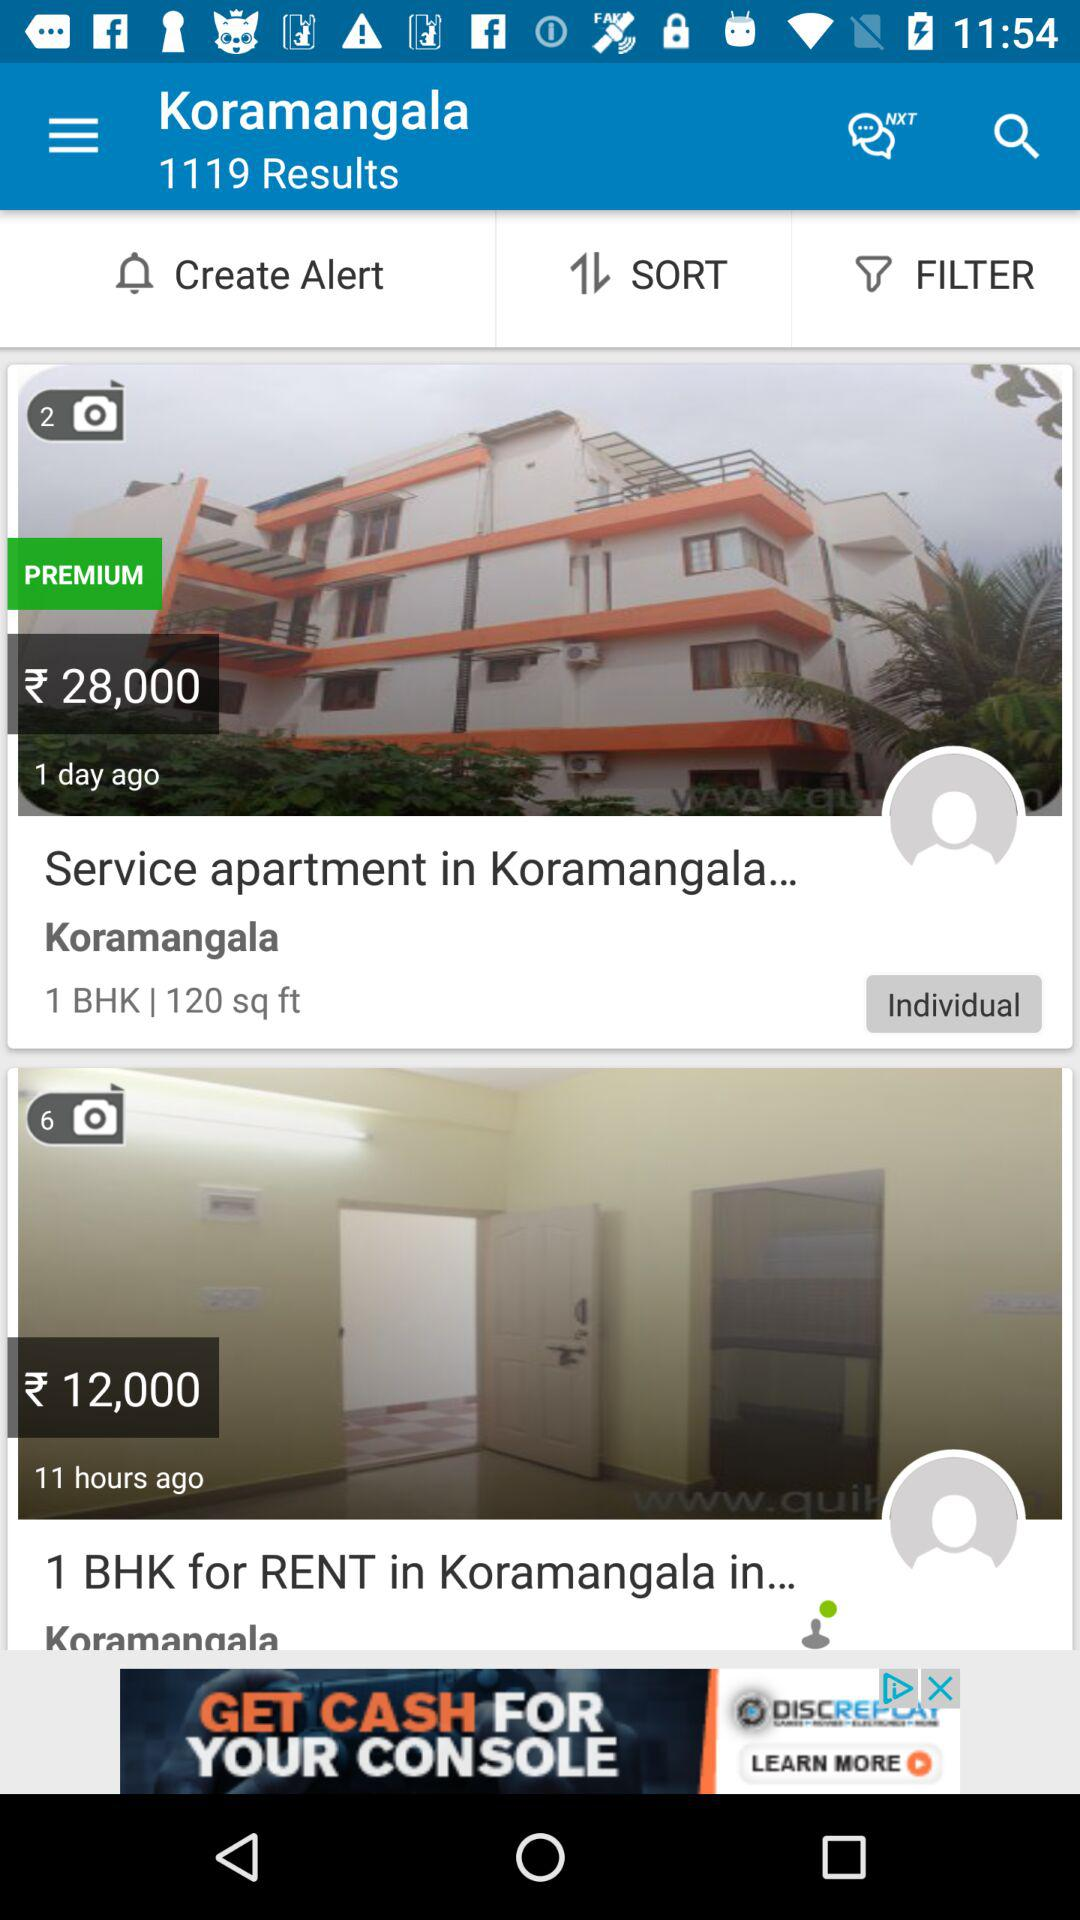What is the price for the service apartment in Koramangala? The price for the service apartment in Koramangala is ₹28,000. 